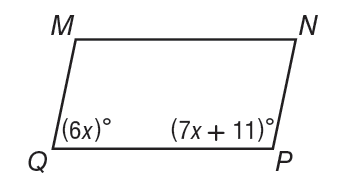Answer the mathemtical geometry problem and directly provide the correct option letter.
Question: Parallelogram M N P Q is shown. What is the value of x?
Choices: A: 13 B: 39 C: 141 D: 169 A 